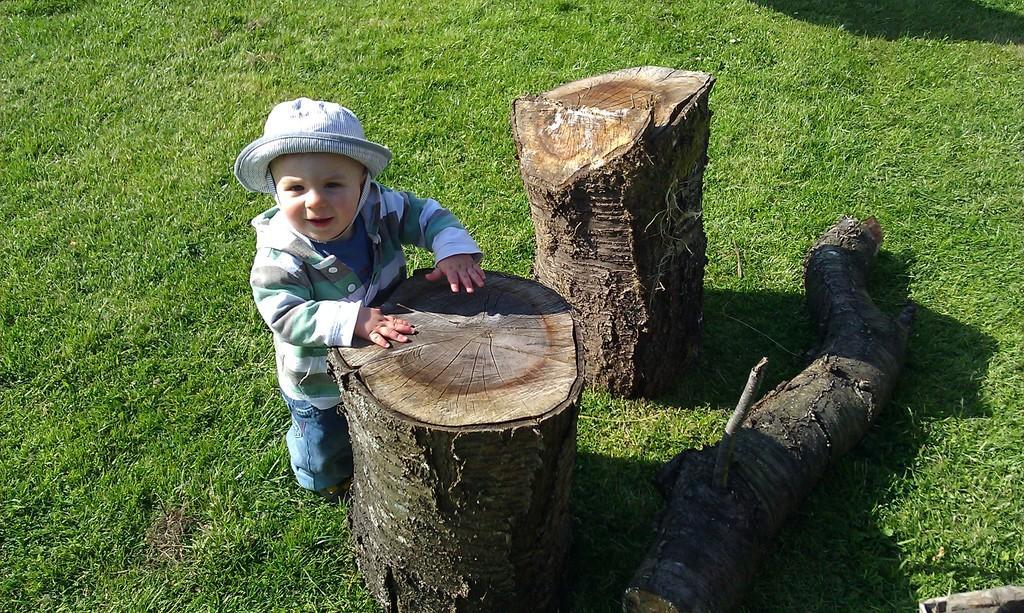In one or two sentences, can you explain what this image depicts? In this image I can see a boy wearing jacket, hat and pant is standing in front of a wooden log. I can see few other wooden logs on the ground and some grass which is green in color. 